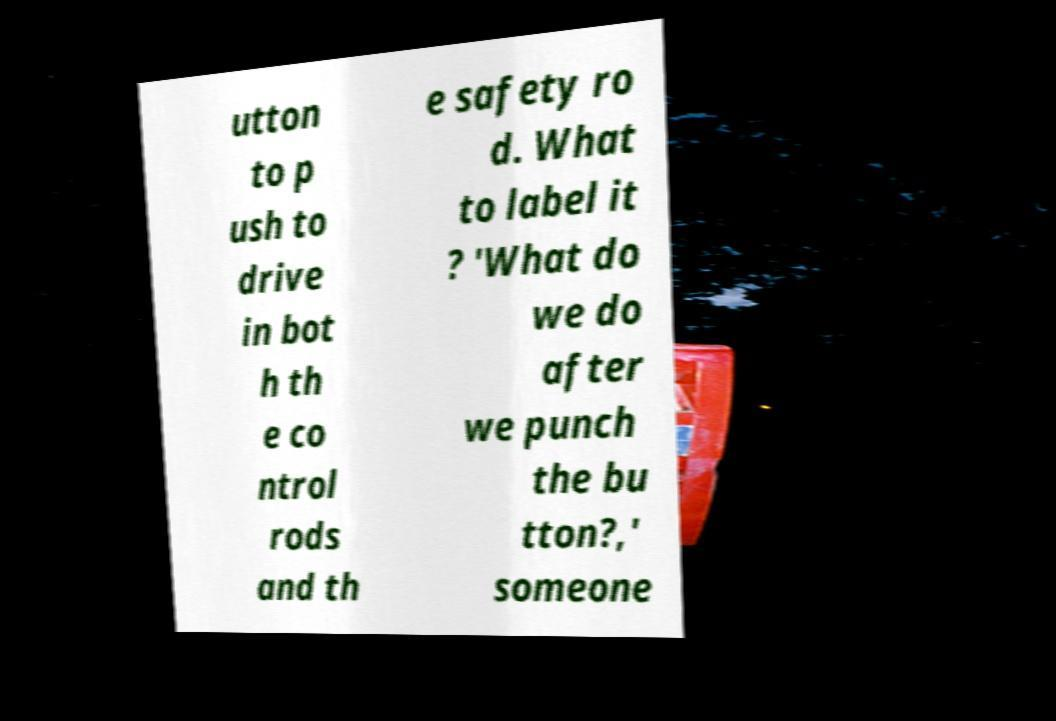Could you extract and type out the text from this image? utton to p ush to drive in bot h th e co ntrol rods and th e safety ro d. What to label it ? 'What do we do after we punch the bu tton?,' someone 